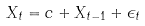<formula> <loc_0><loc_0><loc_500><loc_500>X _ { t } = c + X _ { t - 1 } + \epsilon _ { t }</formula> 